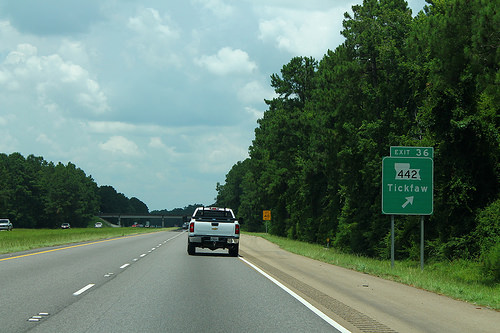<image>
Can you confirm if the car is behind the tree? No. The car is not behind the tree. From this viewpoint, the car appears to be positioned elsewhere in the scene. Is the tree to the right of the car? Yes. From this viewpoint, the tree is positioned to the right side relative to the car. 